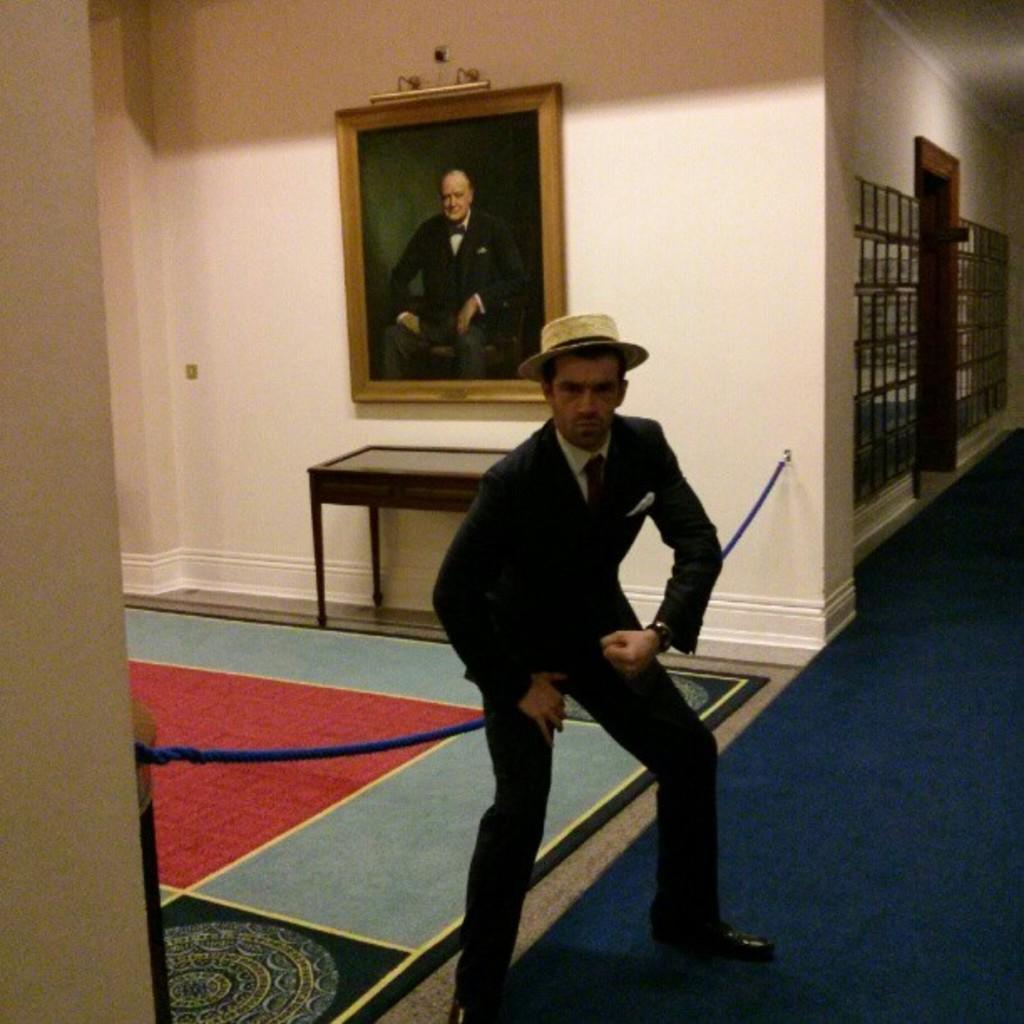Who or what is the main subject in the center of the image? There is a person in the center of the image. What is the person wearing on their head? The person is wearing a hat. What object is located behind the person? There is a table behind the person. What can be seen on the wall behind the table? There is a portrait on the wall behind the table. What type of magic is the person performing in the image? There is no indication of magic or any magical activity in the image. 